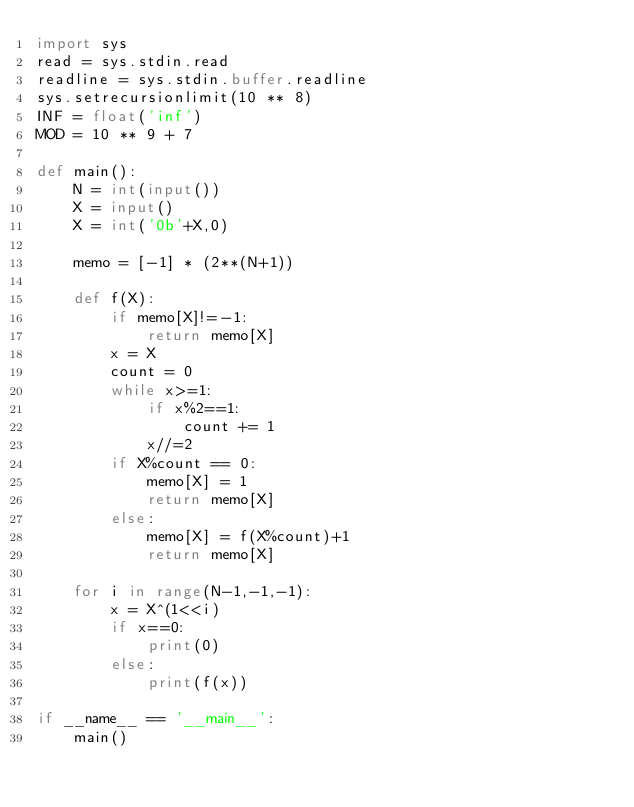Convert code to text. <code><loc_0><loc_0><loc_500><loc_500><_Python_>import sys
read = sys.stdin.read
readline = sys.stdin.buffer.readline
sys.setrecursionlimit(10 ** 8)
INF = float('inf')
MOD = 10 ** 9 + 7

def main():
    N = int(input())
    X = input()
    X = int('0b'+X,0)

    memo = [-1] * (2**(N+1))

    def f(X):
        if memo[X]!=-1:
            return memo[X]
        x = X
        count = 0
        while x>=1:
            if x%2==1:
                count += 1
            x//=2
        if X%count == 0:
            memo[X] = 1
            return memo[X]
        else:
            memo[X] = f(X%count)+1
            return memo[X]

    for i in range(N-1,-1,-1):
        x = X^(1<<i)
        if x==0:
            print(0)
        else:
            print(f(x))

if __name__ == '__main__':
    main()
</code> 